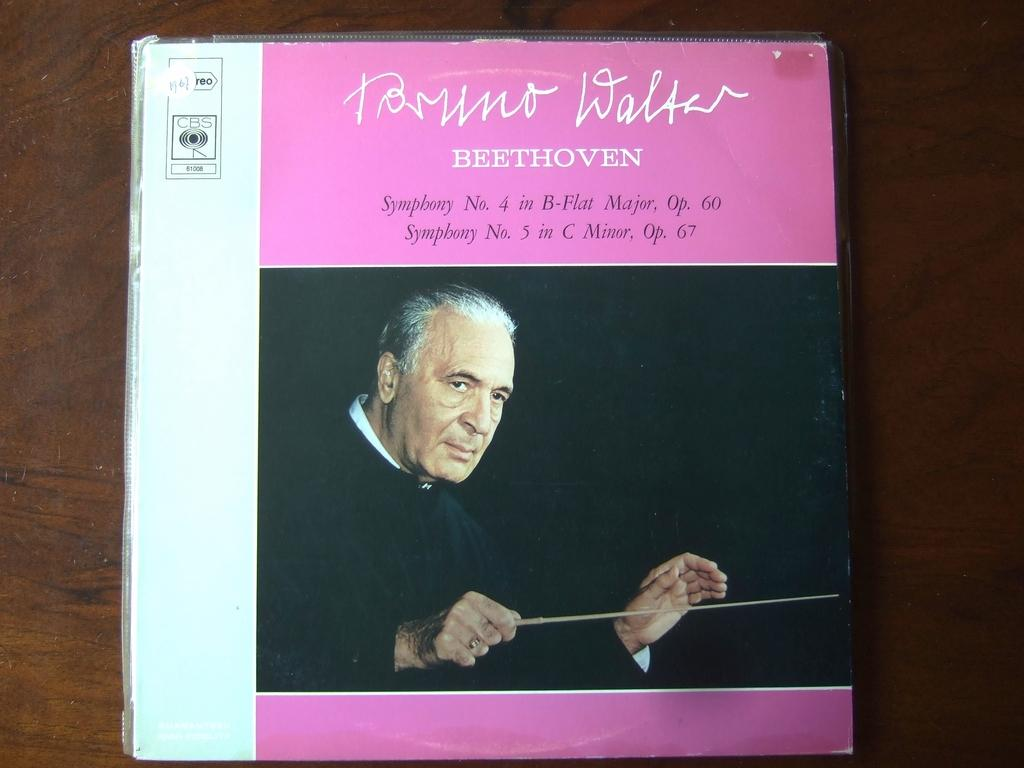<image>
Create a compact narrative representing the image presented. Compact Disc copy of Beethoven that includes symphony 4 and 5. 